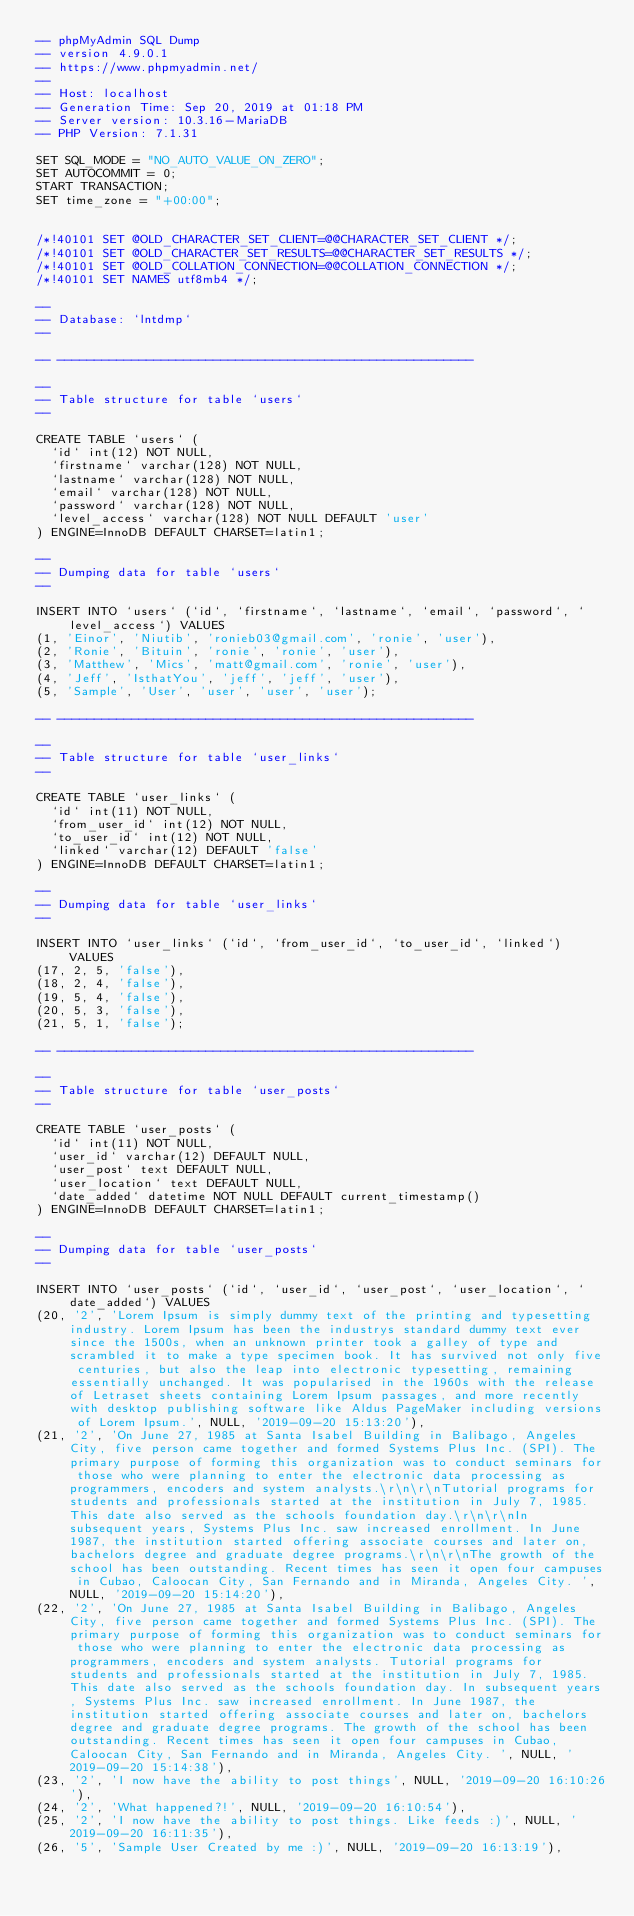<code> <loc_0><loc_0><loc_500><loc_500><_SQL_>-- phpMyAdmin SQL Dump
-- version 4.9.0.1
-- https://www.phpmyadmin.net/
--
-- Host: localhost
-- Generation Time: Sep 20, 2019 at 01:18 PM
-- Server version: 10.3.16-MariaDB
-- PHP Version: 7.1.31

SET SQL_MODE = "NO_AUTO_VALUE_ON_ZERO";
SET AUTOCOMMIT = 0;
START TRANSACTION;
SET time_zone = "+00:00";


/*!40101 SET @OLD_CHARACTER_SET_CLIENT=@@CHARACTER_SET_CLIENT */;
/*!40101 SET @OLD_CHARACTER_SET_RESULTS=@@CHARACTER_SET_RESULTS */;
/*!40101 SET @OLD_COLLATION_CONNECTION=@@COLLATION_CONNECTION */;
/*!40101 SET NAMES utf8mb4 */;

--
-- Database: `lntdmp`
--

-- --------------------------------------------------------

--
-- Table structure for table `users`
--

CREATE TABLE `users` (
  `id` int(12) NOT NULL,
  `firstname` varchar(128) NOT NULL,
  `lastname` varchar(128) NOT NULL,
  `email` varchar(128) NOT NULL,
  `password` varchar(128) NOT NULL,
  `level_access` varchar(128) NOT NULL DEFAULT 'user'
) ENGINE=InnoDB DEFAULT CHARSET=latin1;

--
-- Dumping data for table `users`
--

INSERT INTO `users` (`id`, `firstname`, `lastname`, `email`, `password`, `level_access`) VALUES
(1, 'Einor', 'Niutib', 'ronieb03@gmail.com', 'ronie', 'user'),
(2, 'Ronie', 'Bituin', 'ronie', 'ronie', 'user'),
(3, 'Matthew', 'Mics', 'matt@gmail.com', 'ronie', 'user'),
(4, 'Jeff', 'IsthatYou', 'jeff', 'jeff', 'user'),
(5, 'Sample', 'User', 'user', 'user', 'user');

-- --------------------------------------------------------

--
-- Table structure for table `user_links`
--

CREATE TABLE `user_links` (
  `id` int(11) NOT NULL,
  `from_user_id` int(12) NOT NULL,
  `to_user_id` int(12) NOT NULL,
  `linked` varchar(12) DEFAULT 'false'
) ENGINE=InnoDB DEFAULT CHARSET=latin1;

--
-- Dumping data for table `user_links`
--

INSERT INTO `user_links` (`id`, `from_user_id`, `to_user_id`, `linked`) VALUES
(17, 2, 5, 'false'),
(18, 2, 4, 'false'),
(19, 5, 4, 'false'),
(20, 5, 3, 'false'),
(21, 5, 1, 'false');

-- --------------------------------------------------------

--
-- Table structure for table `user_posts`
--

CREATE TABLE `user_posts` (
  `id` int(11) NOT NULL,
  `user_id` varchar(12) DEFAULT NULL,
  `user_post` text DEFAULT NULL,
  `user_location` text DEFAULT NULL,
  `date_added` datetime NOT NULL DEFAULT current_timestamp()
) ENGINE=InnoDB DEFAULT CHARSET=latin1;

--
-- Dumping data for table `user_posts`
--

INSERT INTO `user_posts` (`id`, `user_id`, `user_post`, `user_location`, `date_added`) VALUES
(20, '2', 'Lorem Ipsum is simply dummy text of the printing and typesetting industry. Lorem Ipsum has been the industrys standard dummy text ever since the 1500s, when an unknown printer took a galley of type and scrambled it to make a type specimen book. It has survived not only five centuries, but also the leap into electronic typesetting, remaining essentially unchanged. It was popularised in the 1960s with the release of Letraset sheets containing Lorem Ipsum passages, and more recently with desktop publishing software like Aldus PageMaker including versions of Lorem Ipsum.', NULL, '2019-09-20 15:13:20'),
(21, '2', 'On June 27, 1985 at Santa Isabel Building in Balibago, Angeles City, five person came together and formed Systems Plus Inc. (SPI). The primary purpose of forming this organization was to conduct seminars for those who were planning to enter the electronic data processing as programmers, encoders and system analysts.\r\n\r\nTutorial programs for students and professionals started at the institution in July 7, 1985. This date also served as the schools foundation day.\r\n\r\nIn subsequent years, Systems Plus Inc. saw increased enrollment. In June 1987, the institution started offering associate courses and later on, bachelors degree and graduate degree programs.\r\n\r\nThe growth of the school has been outstanding. Recent times has seen it open four campuses in Cubao, Caloocan City, San Fernando and in Miranda, Angeles City. ', NULL, '2019-09-20 15:14:20'),
(22, '2', 'On June 27, 1985 at Santa Isabel Building in Balibago, Angeles City, five person came together and formed Systems Plus Inc. (SPI). The primary purpose of forming this organization was to conduct seminars for those who were planning to enter the electronic data processing as programmers, encoders and system analysts. Tutorial programs for students and professionals started at the institution in July 7, 1985. This date also served as the schools foundation day. In subsequent years, Systems Plus Inc. saw increased enrollment. In June 1987, the institution started offering associate courses and later on, bachelors degree and graduate degree programs. The growth of the school has been outstanding. Recent times has seen it open four campuses in Cubao, Caloocan City, San Fernando and in Miranda, Angeles City. ', NULL, '2019-09-20 15:14:38'),
(23, '2', 'I now have the ability to post things', NULL, '2019-09-20 16:10:26'),
(24, '2', 'What happened?!', NULL, '2019-09-20 16:10:54'),
(25, '2', 'I now have the ability to post things. Like feeds :)', NULL, '2019-09-20 16:11:35'),
(26, '5', 'Sample User Created by me :)', NULL, '2019-09-20 16:13:19'),</code> 